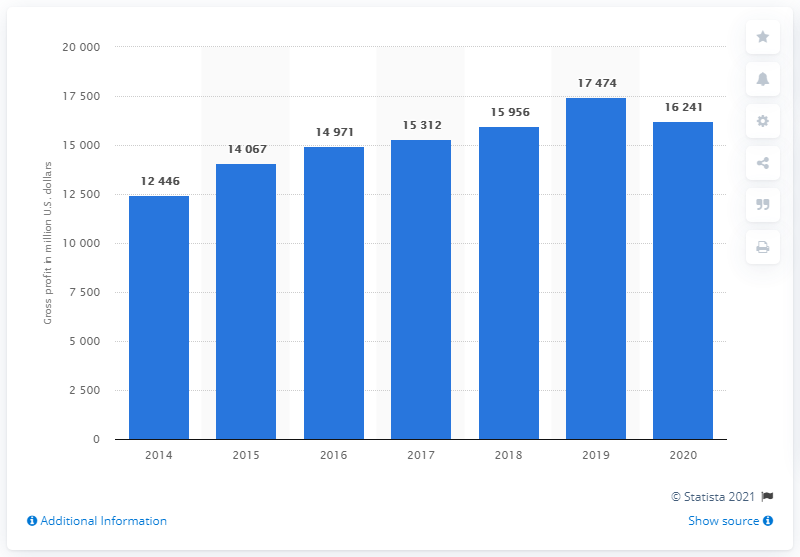What was Nike's global gross profit in dollars in 2020? In 2020, Nike's global gross profit amounted to $16.241 billion, according to the data presented in the bar chart. This figure signifies the revenue Nike retained after incurring the direct costs associated with producing the goods it sold during the year. 